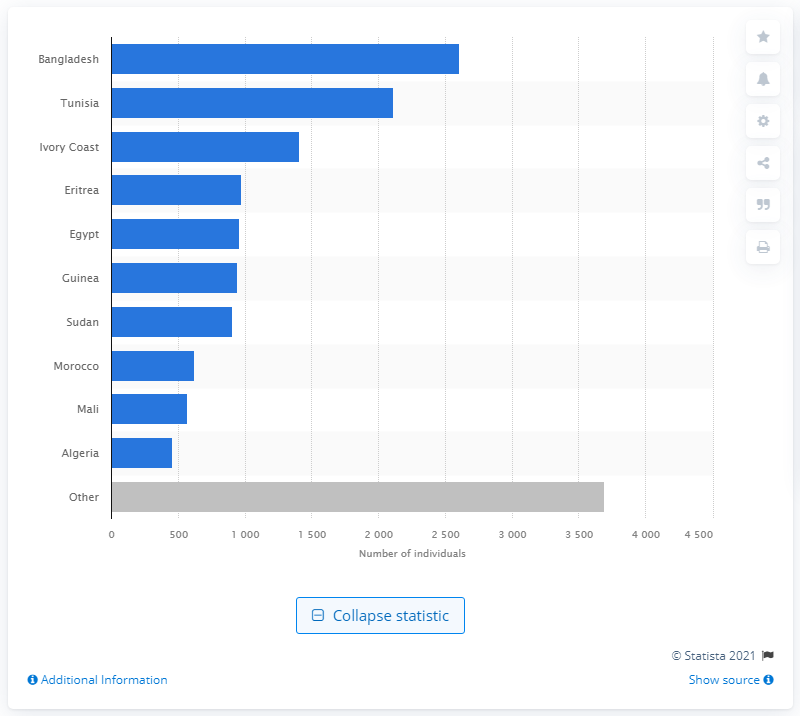Specify some key components in this picture. The exact number of migrants from Tunisia who arrived in Italy in 2021 is 2,113. In 2021, a total of 1,410 immigrants from Ivory Coast arrived in Italy. In 2021, a total of 2,608 immigrants arrived from Bangladesh. 